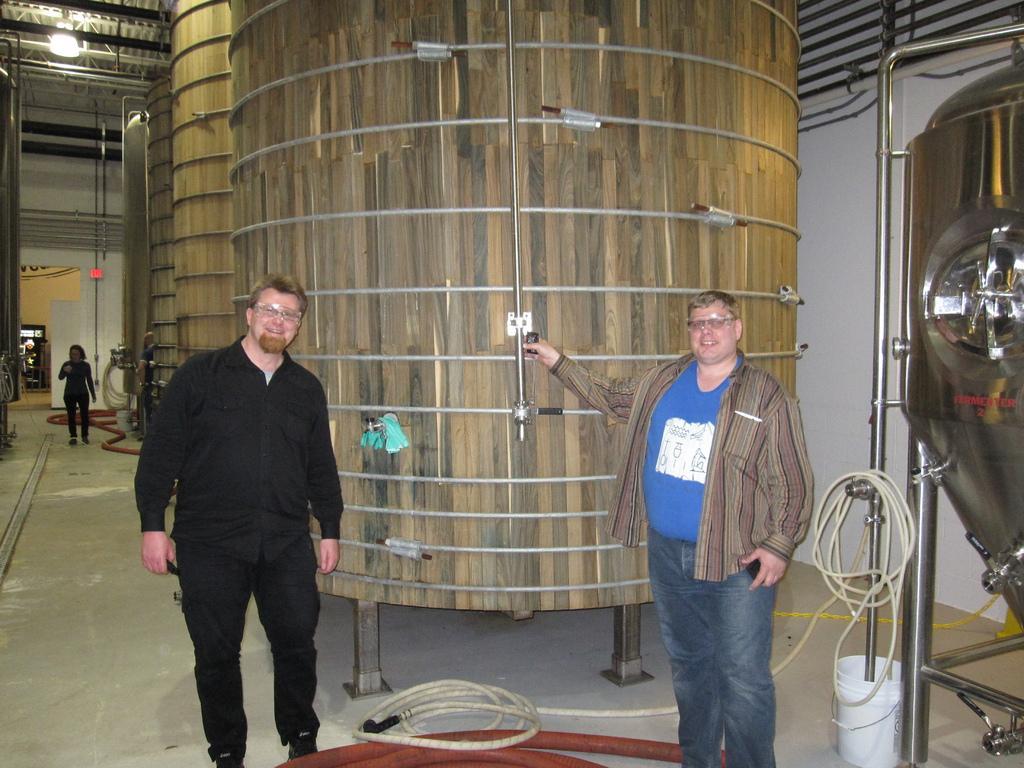Can you describe this image briefly? In this picture we can see three men standing here, on the left side there is a person standing here, we can see a tank here, in the background there is a wall, we can see a light here. 